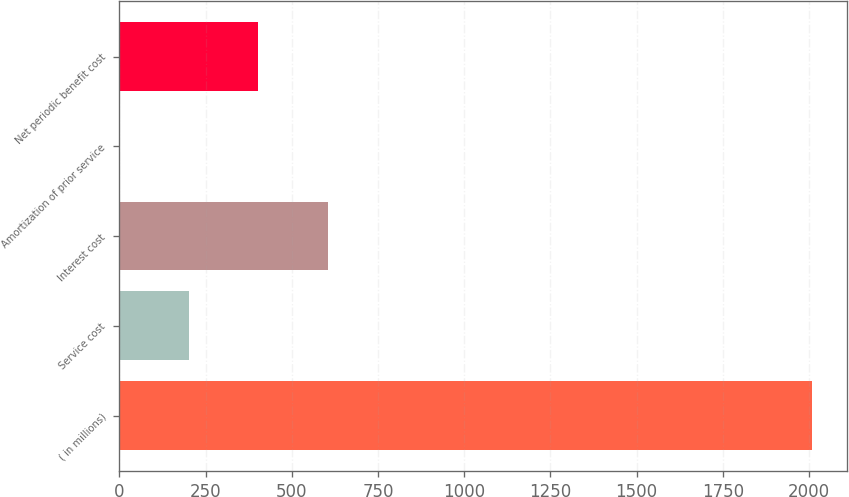Convert chart. <chart><loc_0><loc_0><loc_500><loc_500><bar_chart><fcel>( in millions)<fcel>Service cost<fcel>Interest cost<fcel>Amortization of prior service<fcel>Net periodic benefit cost<nl><fcel>2010<fcel>201.99<fcel>603.77<fcel>1.1<fcel>402.88<nl></chart> 